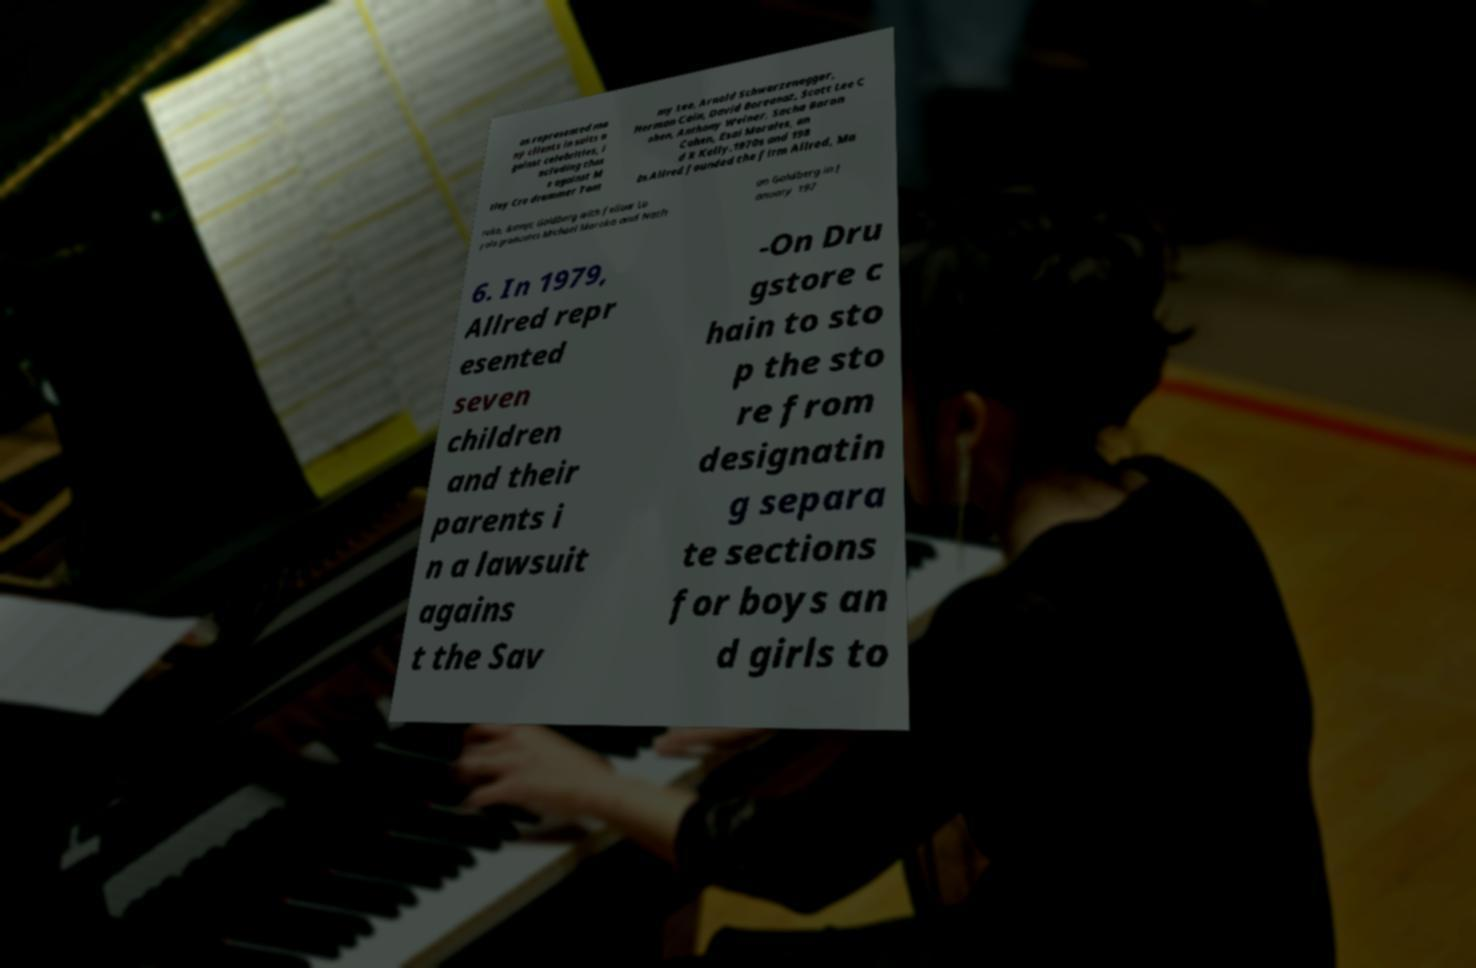Could you extract and type out the text from this image? as represented ma ny clients in suits a gainst celebrities, i ncluding thos e against M tley Cre drummer Tom my Lee, Arnold Schwarzenegger, Herman Cain, David Boreanaz, Scott Lee C ohen, Anthony Weiner, Sacha Baron Cohen, Esai Morales, an d R Kelly.1970s and 198 0s.Allred founded the firm Allred, Ma roko, &amp; Goldberg with fellow Lo yola graduates Michael Maroko and Nath an Goldberg in J anuary 197 6. In 1979, Allred repr esented seven children and their parents i n a lawsuit agains t the Sav -On Dru gstore c hain to sto p the sto re from designatin g separa te sections for boys an d girls to 